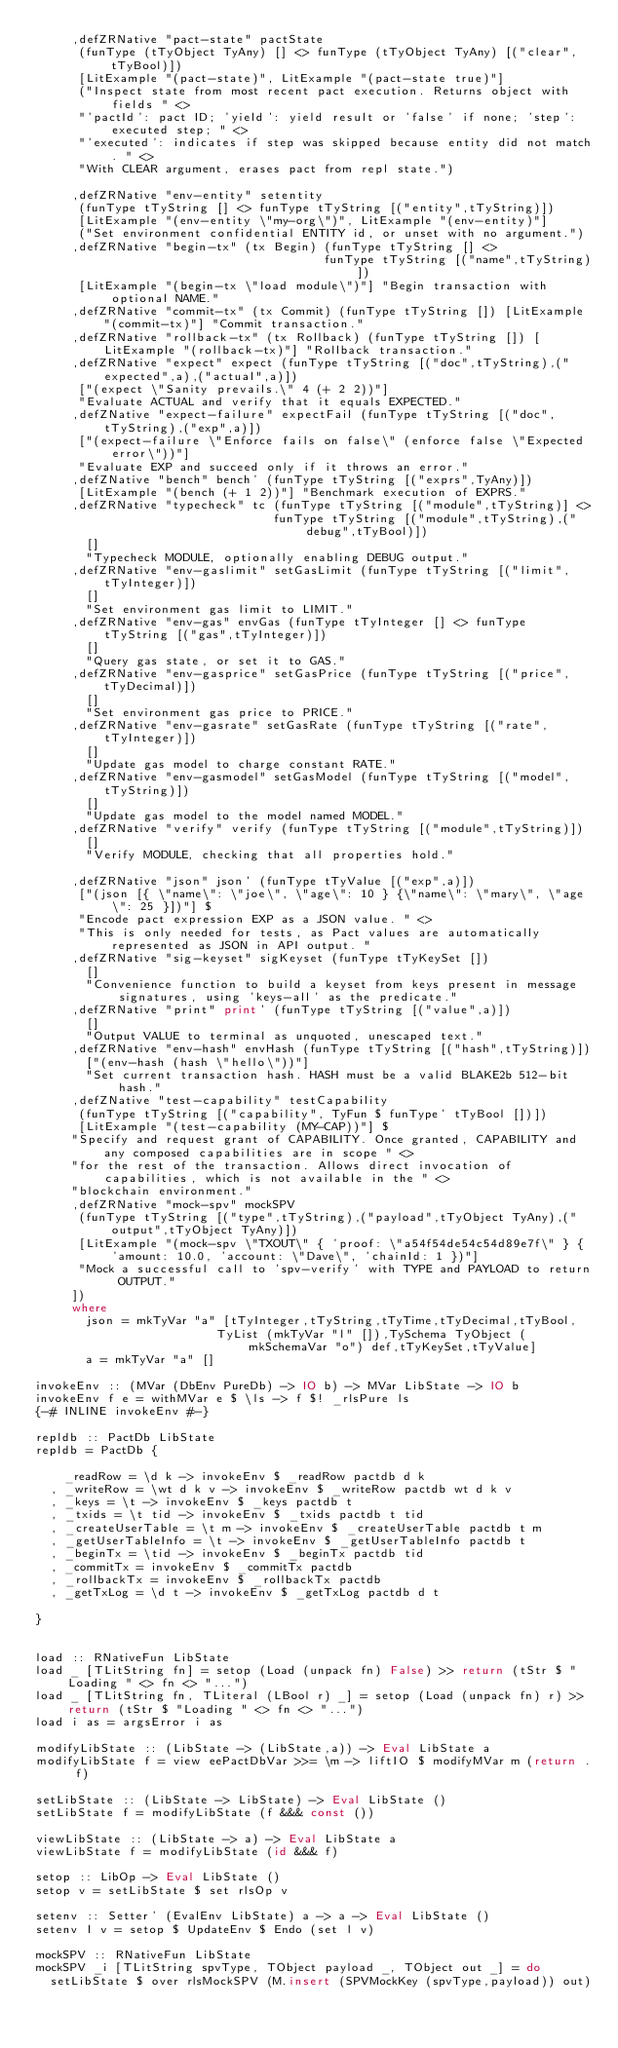<code> <loc_0><loc_0><loc_500><loc_500><_Haskell_>     ,defZRNative "pact-state" pactState
      (funType (tTyObject TyAny) [] <> funType (tTyObject TyAny) [("clear",tTyBool)])
      [LitExample "(pact-state)", LitExample "(pact-state true)"]
      ("Inspect state from most recent pact execution. Returns object with fields " <>
      "'pactId': pact ID; 'yield': yield result or 'false' if none; 'step': executed step; " <>
      "'executed': indicates if step was skipped because entity did not match. " <>
      "With CLEAR argument, erases pact from repl state.")

     ,defZRNative "env-entity" setentity
      (funType tTyString [] <> funType tTyString [("entity",tTyString)])
      [LitExample "(env-entity \"my-org\")", LitExample "(env-entity)"]
      ("Set environment confidential ENTITY id, or unset with no argument.")
     ,defZRNative "begin-tx" (tx Begin) (funType tTyString [] <>
                                        funType tTyString [("name",tTyString)])
      [LitExample "(begin-tx \"load module\")"] "Begin transaction with optional NAME."
     ,defZRNative "commit-tx" (tx Commit) (funType tTyString []) [LitExample "(commit-tx)"] "Commit transaction."
     ,defZRNative "rollback-tx" (tx Rollback) (funType tTyString []) [LitExample "(rollback-tx)"] "Rollback transaction."
     ,defZRNative "expect" expect (funType tTyString [("doc",tTyString),("expected",a),("actual",a)])
      ["(expect \"Sanity prevails.\" 4 (+ 2 2))"]
      "Evaluate ACTUAL and verify that it equals EXPECTED."
     ,defZNative "expect-failure" expectFail (funType tTyString [("doc",tTyString),("exp",a)])
      ["(expect-failure \"Enforce fails on false\" (enforce false \"Expected error\"))"]
      "Evaluate EXP and succeed only if it throws an error."
     ,defZNative "bench" bench' (funType tTyString [("exprs",TyAny)])
      [LitExample "(bench (+ 1 2))"] "Benchmark execution of EXPRS."
     ,defZRNative "typecheck" tc (funType tTyString [("module",tTyString)] <>
                                 funType tTyString [("module",tTyString),("debug",tTyBool)])
       []
       "Typecheck MODULE, optionally enabling DEBUG output."
     ,defZRNative "env-gaslimit" setGasLimit (funType tTyString [("limit",tTyInteger)])
       []
       "Set environment gas limit to LIMIT."
     ,defZRNative "env-gas" envGas (funType tTyInteger [] <> funType tTyString [("gas",tTyInteger)])
       []
       "Query gas state, or set it to GAS."
     ,defZRNative "env-gasprice" setGasPrice (funType tTyString [("price",tTyDecimal)])
       []
       "Set environment gas price to PRICE."
     ,defZRNative "env-gasrate" setGasRate (funType tTyString [("rate",tTyInteger)])
       []
       "Update gas model to charge constant RATE."
     ,defZRNative "env-gasmodel" setGasModel (funType tTyString [("model",tTyString)])
       []
       "Update gas model to the model named MODEL."
     ,defZRNative "verify" verify (funType tTyString [("module",tTyString)])
       []
       "Verify MODULE, checking that all properties hold."

     ,defZRNative "json" json' (funType tTyValue [("exp",a)])
      ["(json [{ \"name\": \"joe\", \"age\": 10 } {\"name\": \"mary\", \"age\": 25 }])"] $
      "Encode pact expression EXP as a JSON value. " <>
      "This is only needed for tests, as Pact values are automatically represented as JSON in API output. "
     ,defZRNative "sig-keyset" sigKeyset (funType tTyKeySet [])
       []
       "Convenience function to build a keyset from keys present in message signatures, using 'keys-all' as the predicate."
     ,defZRNative "print" print' (funType tTyString [("value",a)])
       []
       "Output VALUE to terminal as unquoted, unescaped text."
     ,defZRNative "env-hash" envHash (funType tTyString [("hash",tTyString)])
       ["(env-hash (hash \"hello\"))"]
       "Set current transaction hash. HASH must be a valid BLAKE2b 512-bit hash."
     ,defZNative "test-capability" testCapability
      (funType tTyString [("capability", TyFun $ funType' tTyBool [])])
      [LitExample "(test-capability (MY-CAP))"] $
     "Specify and request grant of CAPABILITY. Once granted, CAPABILITY and any composed capabilities are in scope " <>
     "for the rest of the transaction. Allows direct invocation of capabilities, which is not available in the " <>
     "blockchain environment."
     ,defZRNative "mock-spv" mockSPV
      (funType tTyString [("type",tTyString),("payload",tTyObject TyAny),("output",tTyObject TyAny)])
      [LitExample "(mock-spv \"TXOUT\" { 'proof: \"a54f54de54c54d89e7f\" } { 'amount: 10.0, 'account: \"Dave\", 'chainId: 1 })"]
      "Mock a successful call to 'spv-verify' with TYPE and PAYLOAD to return OUTPUT."
     ])
     where
       json = mkTyVar "a" [tTyInteger,tTyString,tTyTime,tTyDecimal,tTyBool,
                         TyList (mkTyVar "l" []),TySchema TyObject (mkSchemaVar "o") def,tTyKeySet,tTyValue]
       a = mkTyVar "a" []

invokeEnv :: (MVar (DbEnv PureDb) -> IO b) -> MVar LibState -> IO b
invokeEnv f e = withMVar e $ \ls -> f $! _rlsPure ls
{-# INLINE invokeEnv #-}

repldb :: PactDb LibState
repldb = PactDb {

    _readRow = \d k -> invokeEnv $ _readRow pactdb d k
  , _writeRow = \wt d k v -> invokeEnv $ _writeRow pactdb wt d k v
  , _keys = \t -> invokeEnv $ _keys pactdb t
  , _txids = \t tid -> invokeEnv $ _txids pactdb t tid
  , _createUserTable = \t m -> invokeEnv $ _createUserTable pactdb t m
  , _getUserTableInfo = \t -> invokeEnv $ _getUserTableInfo pactdb t
  , _beginTx = \tid -> invokeEnv $ _beginTx pactdb tid
  , _commitTx = invokeEnv $ _commitTx pactdb
  , _rollbackTx = invokeEnv $ _rollbackTx pactdb
  , _getTxLog = \d t -> invokeEnv $ _getTxLog pactdb d t

}


load :: RNativeFun LibState
load _ [TLitString fn] = setop (Load (unpack fn) False) >> return (tStr $ "Loading " <> fn <> "...")
load _ [TLitString fn, TLiteral (LBool r) _] = setop (Load (unpack fn) r) >> return (tStr $ "Loading " <> fn <> "...")
load i as = argsError i as

modifyLibState :: (LibState -> (LibState,a)) -> Eval LibState a
modifyLibState f = view eePactDbVar >>= \m -> liftIO $ modifyMVar m (return . f)

setLibState :: (LibState -> LibState) -> Eval LibState ()
setLibState f = modifyLibState (f &&& const ())

viewLibState :: (LibState -> a) -> Eval LibState a
viewLibState f = modifyLibState (id &&& f)

setop :: LibOp -> Eval LibState ()
setop v = setLibState $ set rlsOp v

setenv :: Setter' (EvalEnv LibState) a -> a -> Eval LibState ()
setenv l v = setop $ UpdateEnv $ Endo (set l v)

mockSPV :: RNativeFun LibState
mockSPV _i [TLitString spvType, TObject payload _, TObject out _] = do
  setLibState $ over rlsMockSPV (M.insert (SPVMockKey (spvType,payload)) out)</code> 